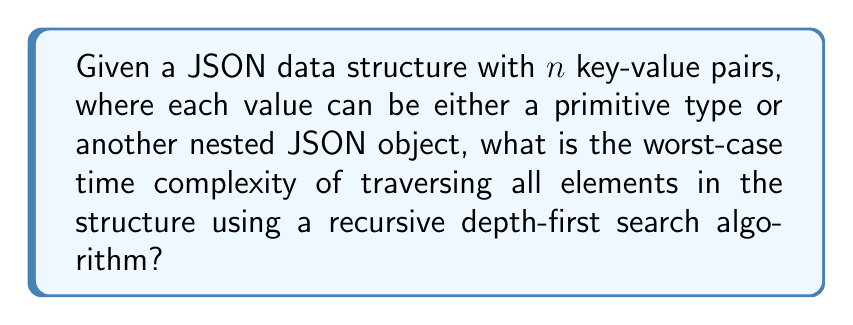Help me with this question. To analyze the time complexity of traversing a JSON data structure using recursive depth-first search (DFS), we need to consider the following steps:

1. In the worst-case scenario, the JSON structure is deeply nested, forming a linear chain of nested objects.

2. For each key-value pair:
   a. We spend constant time $O(1)$ to process the key.
   b. If the value is a primitive type, we spend $O(1)$ time to process it.
   c. If the value is another JSON object, we make a recursive call.

3. In the worst case, we have $n$ key-value pairs, and each pair leads to a nested object, creating a chain of depth $n$.

4. The recurrence relation for this scenario can be expressed as:
   $$T(n) = T(n-1) + O(1)$$
   where $T(n)$ is the time complexity for $n$ key-value pairs.

5. Expanding this recurrence relation:
   $$\begin{align}
   T(n) &= T(n-1) + O(1) \\
        &= (T(n-2) + O(1)) + O(1) \\
        &= T(n-2) + O(1) + O(1) \\
        &= T(n-3) + O(1) + O(1) + O(1) \\
        &= ... \\
        &= T(1) + (n-1) \cdot O(1)
   \end{align}$$

6. Since $T(1) = O(1)$, we can simplify:
   $$T(n) = O(1) + (n-1) \cdot O(1) = O(n)$$

Therefore, the worst-case time complexity of traversing all elements in the JSON structure using a recursive depth-first search algorithm is $O(n)$, where $n$ is the total number of key-value pairs in the structure.
Answer: $O(n)$ 